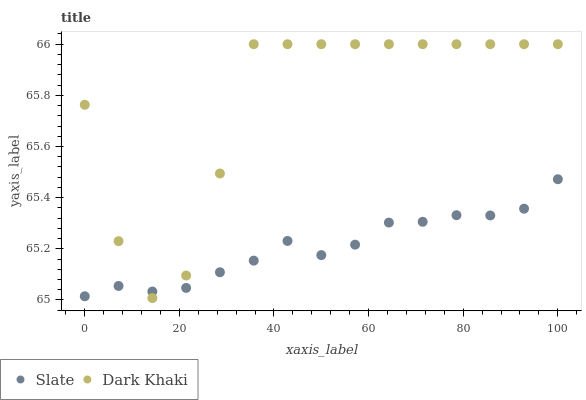Does Slate have the minimum area under the curve?
Answer yes or no. Yes. Does Dark Khaki have the maximum area under the curve?
Answer yes or no. Yes. Does Slate have the maximum area under the curve?
Answer yes or no. No. Is Slate the smoothest?
Answer yes or no. Yes. Is Dark Khaki the roughest?
Answer yes or no. Yes. Is Slate the roughest?
Answer yes or no. No. Does Dark Khaki have the lowest value?
Answer yes or no. Yes. Does Slate have the lowest value?
Answer yes or no. No. Does Dark Khaki have the highest value?
Answer yes or no. Yes. Does Slate have the highest value?
Answer yes or no. No. Does Slate intersect Dark Khaki?
Answer yes or no. Yes. Is Slate less than Dark Khaki?
Answer yes or no. No. Is Slate greater than Dark Khaki?
Answer yes or no. No. 